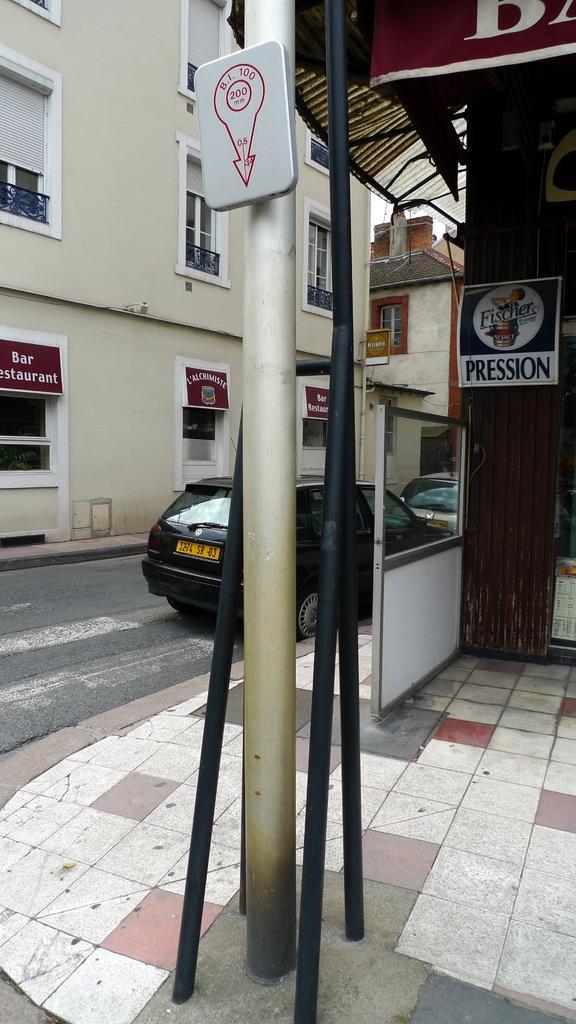Could you give a brief overview of what you see in this image? In this image I can see few poles in the front and on one pole I can see a sign board. In the background I can see a road and on it I can see two cars. On the both side of the road I can see few buildings, number of boards and on these boards I can see something is written. 